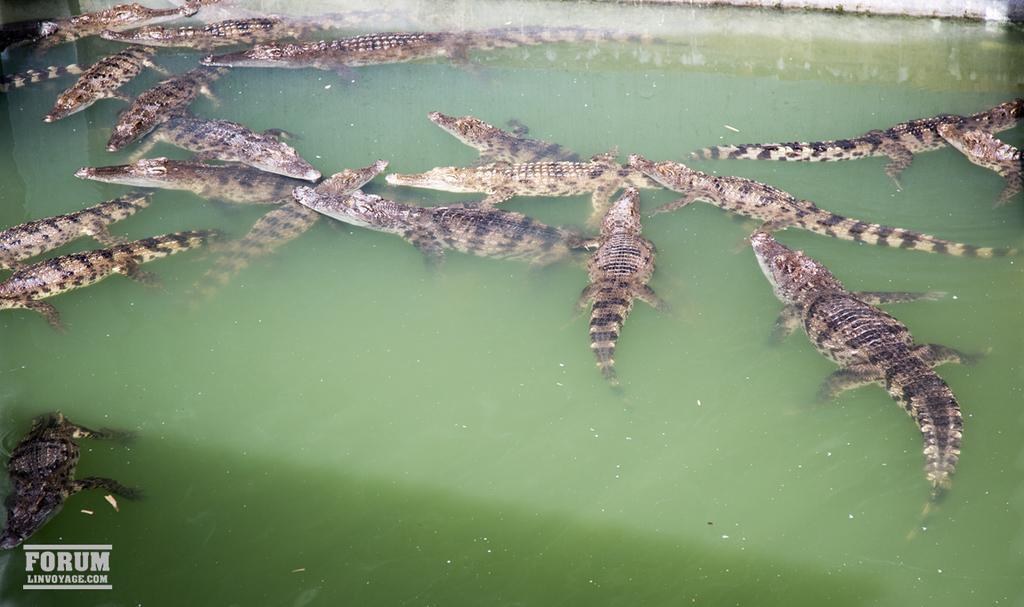How would you summarize this image in a sentence or two? In this image I can see crocodiles in water. And in the bottom left corner there is a watermark. 